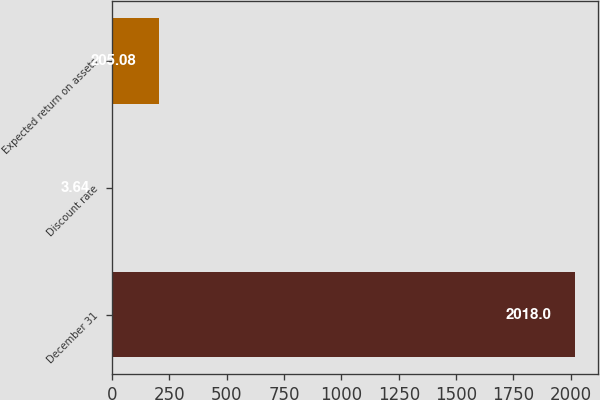<chart> <loc_0><loc_0><loc_500><loc_500><bar_chart><fcel>December 31<fcel>Discount rate<fcel>Expected return on assets<nl><fcel>2018<fcel>3.64<fcel>205.08<nl></chart> 